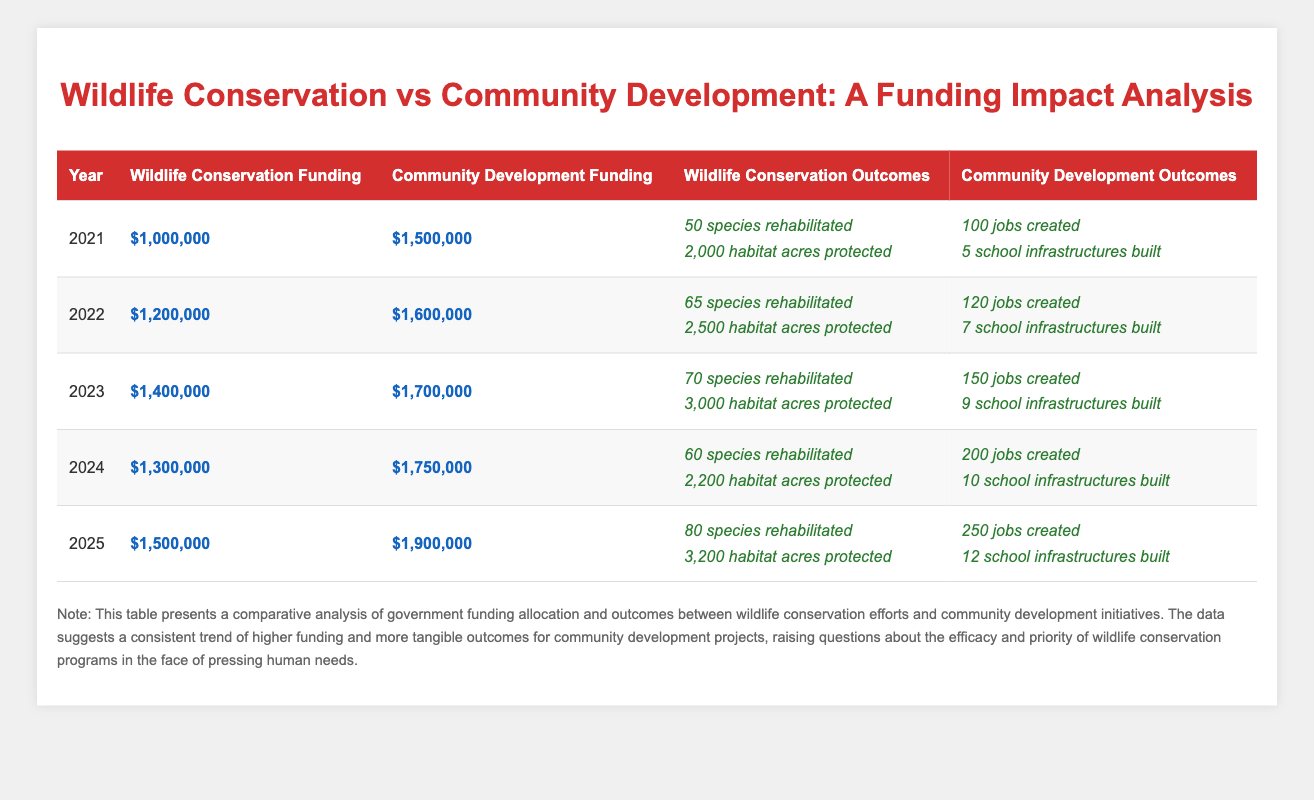What was the total funding for wildlife conservation in 2023? In 2023, the government funding for wildlife conservation was listed as $1,400,000.
Answer: 1,400,000 How many species were rehabilitated in 2024? According to the table, in 2024, 60 species were rehabilitated as reported under wildlife conservation outcomes.
Answer: 60 In which year was the community development funding the highest, and what was that amount? By checking the community development funding values for each year, we see that 2025 had the highest funding at $1,900,000.
Answer: 2025, 1,900,000 What is the difference in total jobs created between 2021 and 2025? For 2021, 100 jobs were created and for 2025, 250. The difference is calculated as 250 - 100 = 150 jobs.
Answer: 150 Was the number of habitat acres protected in 2022 greater than in 2024? Comparing the habitat acres protected in each year, in 2022 it was 2,500 acres, while in 2024 it was 2,200 acres. Since 2,500 is greater than 2,200, the answer is yes.
Answer: Yes What was the average number of jobs created across all years? To find the average, we sum the jobs created: 100 + 120 + 150 + 200 + 250 = 820 jobs and then divide by the number of years (5), which equals 820 / 5 = 164.
Answer: 164 How many habitat acres were protected in total from 2021 to 2025? The total habitat acres protected can be calculated by adding the values: 2000 + 2500 + 3000 + 2200 + 3200 = 12900 acres protected in total.
Answer: 12900 Did funding for wildlife conservation increase every year from 2021 to 2025? By checking the values, the funding increased from 1,000,000 to 1,400,000 in 2023, then decreased to 1,300,000 in 2024 before rising again to 1,500,000 in 2025. Therefore, it did not consistently increase.
Answer: No In which year did community development efforts achieve the highest number of school infrastructures built? Looking at the community development outcomes, 2025 had the highest number of school infrastructures built, which was 12.
Answer: 2025, 12 